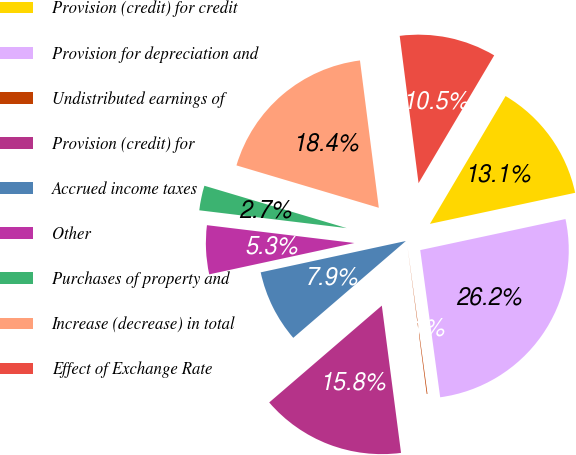Convert chart to OTSL. <chart><loc_0><loc_0><loc_500><loc_500><pie_chart><fcel>Provision (credit) for credit<fcel>Provision for depreciation and<fcel>Undistributed earnings of<fcel>Provision (credit) for<fcel>Accrued income taxes<fcel>Other<fcel>Purchases of property and<fcel>Increase (decrease) in total<fcel>Effect of Exchange Rate<nl><fcel>13.14%<fcel>26.21%<fcel>0.08%<fcel>15.76%<fcel>7.92%<fcel>5.3%<fcel>2.69%<fcel>18.37%<fcel>10.53%<nl></chart> 